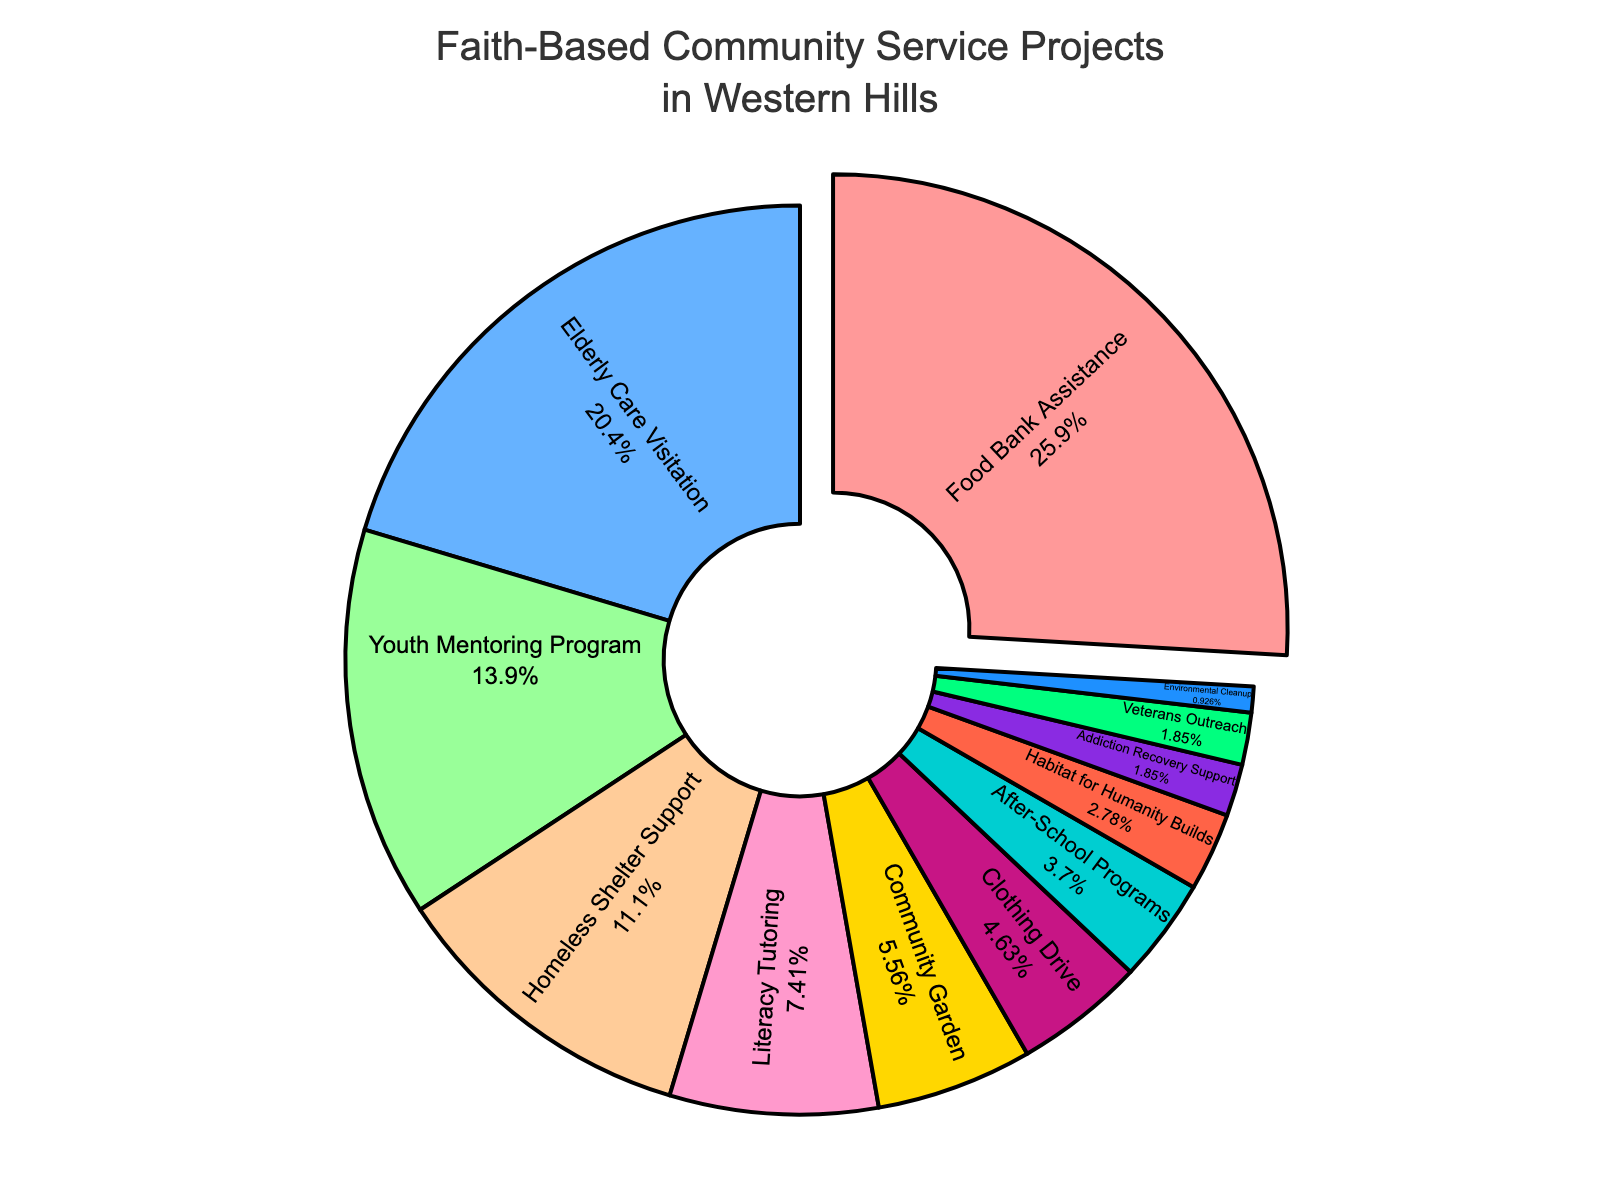What is the most common type of community service project? Look for the largest slice in the pie chart. The label on this slice will tell you the most common type of community service project.
Answer: Food Bank Assistance How much more percentage of projects is focused on Elderly Care Visitation compared to Community Garden? Check the percentages for both Elderly Care Visitation and Community Garden. Subtract the percentage for Community Garden from the percentage for Elderly Care Visitation. 22% - 6% = 16%
Answer: 16% Which project type takes up a smaller percentage, Clothing Drive or After-School Programs? Look at the slices labeled Clothing Drive and After-School Programs. Compare their percentages. Clothing Drive is 5% while After-School Programs is 4%.
Answer: After-School Programs What is the total percentage of projects focused on helping specific vulnerable groups (Elderly Care Visitation, Youth Mentoring Program, Homeless Shelter Support)? Add up the percentages for Elderly Care Visitation, Youth Mentoring Program, and Homeless Shelter Support. 22% + 15% + 12% = 49%
Answer: 49% Which slice is visually largest and what percentage does it represent? Look for the slice that appears largest on the pie chart. The corresponding label will tell you the percentage.
Answer: Food Bank Assistance, 28% What percentage of the projects are focused on environmental and animal care (Environmental Cleanup and Community Garden)? Add the percentages for Environmental Cleanup and Community Garden. 1% + 6% = 7%
Answer: 7% What types of projects each make up less than 5% of the total and what are their combined percentages? Look for slices with percentages less than 5%. This includes After-School Programs, Habitat for Humanity Builds, Addiction Recovery Support, Veterans Outreach, and Environmental Cleanup. Add their percentages. 4% + 3% + 2% + 2% + 1% = 12%
Answer: 12% How does the Clothing Drive's percentage compare to the Literacy Tutoring's percentage? Check the percentages of Clothing Drive and Literacy Tutoring. Clothing Drive is 5%, Literacy Tutoring is 8%. Compare them directly.
Answer: Clothing Drive is 3% less than Literacy Tutoring What is the average percentage of the top three most common project types? Identify the top three most common project types and their percentages: Food Bank Assistance (28%), Elderly Care Visitation (22%), and Youth Mentoring Program (15%). Calculate the average: (28% + 22% + 15%) / 3 = 21.67%
Answer: 21.67% What is the difference in percentages between the top and bottom project types? Identify the top project type (Food Bank Assistance, 28%) and the bottom project type (Environmental Cleanup, 1%). Subtract the bottom percentage from the top percentage: 28% - 1% = 27%
Answer: 27% 